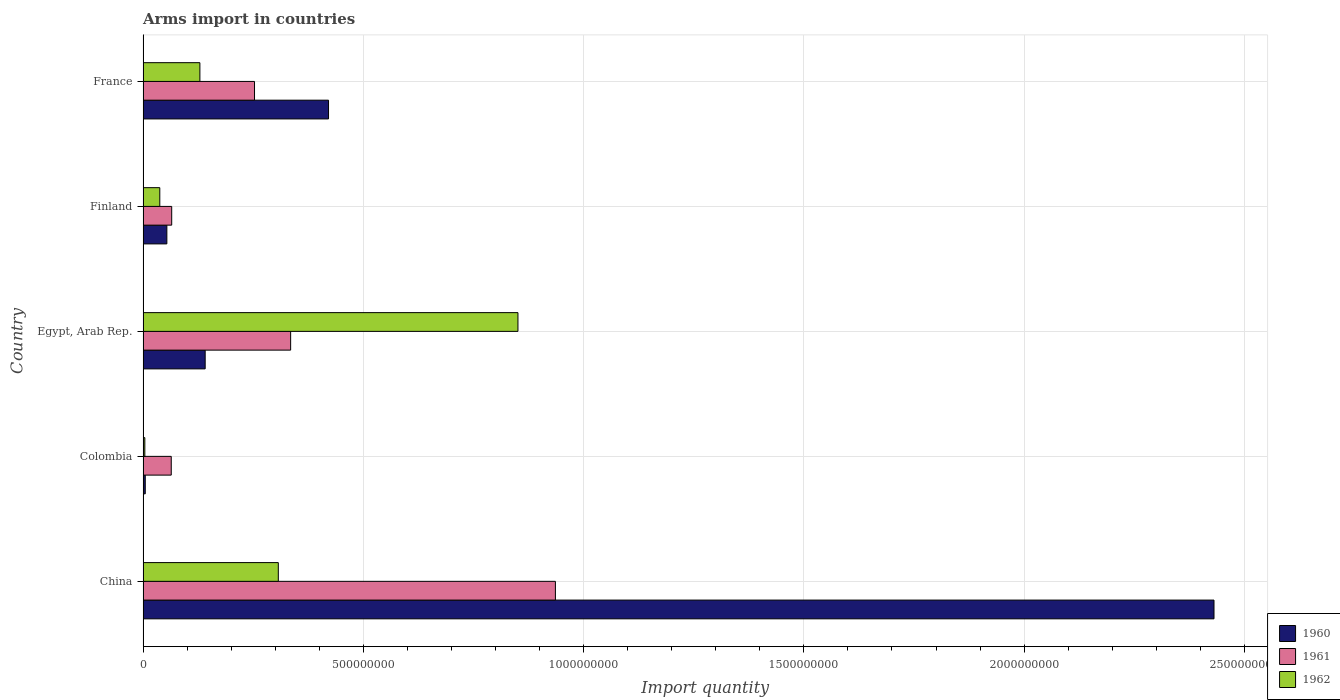How many different coloured bars are there?
Offer a terse response. 3. Are the number of bars per tick equal to the number of legend labels?
Offer a very short reply. Yes. What is the label of the 2nd group of bars from the top?
Give a very brief answer. Finland. In how many cases, is the number of bars for a given country not equal to the number of legend labels?
Your answer should be very brief. 0. What is the total arms import in 1960 in Finland?
Your response must be concise. 5.40e+07. Across all countries, what is the maximum total arms import in 1961?
Offer a very short reply. 9.36e+08. In which country was the total arms import in 1960 minimum?
Your response must be concise. Colombia. What is the total total arms import in 1960 in the graph?
Provide a succinct answer. 3.05e+09. What is the difference between the total arms import in 1960 in China and that in Finland?
Give a very brief answer. 2.38e+09. What is the difference between the total arms import in 1962 in China and the total arms import in 1960 in Colombia?
Your answer should be compact. 3.02e+08. What is the average total arms import in 1962 per country?
Give a very brief answer. 2.66e+08. What is the difference between the total arms import in 1960 and total arms import in 1961 in Egypt, Arab Rep.?
Give a very brief answer. -1.94e+08. In how many countries, is the total arms import in 1962 greater than 1700000000 ?
Keep it short and to the point. 0. What is the ratio of the total arms import in 1960 in Colombia to that in France?
Your answer should be compact. 0.01. What is the difference between the highest and the second highest total arms import in 1962?
Your answer should be compact. 5.44e+08. What is the difference between the highest and the lowest total arms import in 1960?
Give a very brief answer. 2.43e+09. In how many countries, is the total arms import in 1961 greater than the average total arms import in 1961 taken over all countries?
Provide a short and direct response. 2. Is the sum of the total arms import in 1962 in China and Colombia greater than the maximum total arms import in 1961 across all countries?
Ensure brevity in your answer.  No. What does the 1st bar from the top in Finland represents?
Offer a very short reply. 1962. What does the 3rd bar from the bottom in Finland represents?
Offer a very short reply. 1962. How many bars are there?
Your response must be concise. 15. Are all the bars in the graph horizontal?
Your response must be concise. Yes. How many countries are there in the graph?
Make the answer very short. 5. What is the difference between two consecutive major ticks on the X-axis?
Make the answer very short. 5.00e+08. How many legend labels are there?
Provide a short and direct response. 3. How are the legend labels stacked?
Your response must be concise. Vertical. What is the title of the graph?
Make the answer very short. Arms import in countries. What is the label or title of the X-axis?
Your response must be concise. Import quantity. What is the label or title of the Y-axis?
Ensure brevity in your answer.  Country. What is the Import quantity in 1960 in China?
Provide a short and direct response. 2.43e+09. What is the Import quantity in 1961 in China?
Ensure brevity in your answer.  9.36e+08. What is the Import quantity in 1962 in China?
Your response must be concise. 3.07e+08. What is the Import quantity of 1961 in Colombia?
Keep it short and to the point. 6.40e+07. What is the Import quantity of 1962 in Colombia?
Your answer should be very brief. 4.00e+06. What is the Import quantity in 1960 in Egypt, Arab Rep.?
Provide a short and direct response. 1.41e+08. What is the Import quantity of 1961 in Egypt, Arab Rep.?
Offer a terse response. 3.35e+08. What is the Import quantity in 1962 in Egypt, Arab Rep.?
Keep it short and to the point. 8.51e+08. What is the Import quantity in 1960 in Finland?
Provide a succinct answer. 5.40e+07. What is the Import quantity in 1961 in Finland?
Make the answer very short. 6.50e+07. What is the Import quantity in 1962 in Finland?
Make the answer very short. 3.80e+07. What is the Import quantity in 1960 in France?
Keep it short and to the point. 4.21e+08. What is the Import quantity of 1961 in France?
Make the answer very short. 2.53e+08. What is the Import quantity in 1962 in France?
Keep it short and to the point. 1.29e+08. Across all countries, what is the maximum Import quantity in 1960?
Your answer should be very brief. 2.43e+09. Across all countries, what is the maximum Import quantity in 1961?
Offer a terse response. 9.36e+08. Across all countries, what is the maximum Import quantity of 1962?
Your answer should be very brief. 8.51e+08. Across all countries, what is the minimum Import quantity in 1960?
Your response must be concise. 5.00e+06. Across all countries, what is the minimum Import quantity of 1961?
Offer a very short reply. 6.40e+07. Across all countries, what is the minimum Import quantity of 1962?
Offer a very short reply. 4.00e+06. What is the total Import quantity in 1960 in the graph?
Your response must be concise. 3.05e+09. What is the total Import quantity in 1961 in the graph?
Your answer should be compact. 1.65e+09. What is the total Import quantity in 1962 in the graph?
Offer a very short reply. 1.33e+09. What is the difference between the Import quantity in 1960 in China and that in Colombia?
Your response must be concise. 2.43e+09. What is the difference between the Import quantity in 1961 in China and that in Colombia?
Make the answer very short. 8.72e+08. What is the difference between the Import quantity in 1962 in China and that in Colombia?
Provide a succinct answer. 3.03e+08. What is the difference between the Import quantity of 1960 in China and that in Egypt, Arab Rep.?
Your response must be concise. 2.29e+09. What is the difference between the Import quantity in 1961 in China and that in Egypt, Arab Rep.?
Give a very brief answer. 6.01e+08. What is the difference between the Import quantity of 1962 in China and that in Egypt, Arab Rep.?
Your answer should be compact. -5.44e+08. What is the difference between the Import quantity in 1960 in China and that in Finland?
Your answer should be very brief. 2.38e+09. What is the difference between the Import quantity of 1961 in China and that in Finland?
Provide a succinct answer. 8.71e+08. What is the difference between the Import quantity in 1962 in China and that in Finland?
Keep it short and to the point. 2.69e+08. What is the difference between the Import quantity of 1960 in China and that in France?
Ensure brevity in your answer.  2.01e+09. What is the difference between the Import quantity of 1961 in China and that in France?
Make the answer very short. 6.83e+08. What is the difference between the Import quantity of 1962 in China and that in France?
Offer a terse response. 1.78e+08. What is the difference between the Import quantity in 1960 in Colombia and that in Egypt, Arab Rep.?
Offer a terse response. -1.36e+08. What is the difference between the Import quantity of 1961 in Colombia and that in Egypt, Arab Rep.?
Make the answer very short. -2.71e+08. What is the difference between the Import quantity of 1962 in Colombia and that in Egypt, Arab Rep.?
Provide a short and direct response. -8.47e+08. What is the difference between the Import quantity in 1960 in Colombia and that in Finland?
Provide a short and direct response. -4.90e+07. What is the difference between the Import quantity in 1962 in Colombia and that in Finland?
Your answer should be very brief. -3.40e+07. What is the difference between the Import quantity in 1960 in Colombia and that in France?
Your response must be concise. -4.16e+08. What is the difference between the Import quantity in 1961 in Colombia and that in France?
Keep it short and to the point. -1.89e+08. What is the difference between the Import quantity of 1962 in Colombia and that in France?
Give a very brief answer. -1.25e+08. What is the difference between the Import quantity in 1960 in Egypt, Arab Rep. and that in Finland?
Offer a terse response. 8.70e+07. What is the difference between the Import quantity of 1961 in Egypt, Arab Rep. and that in Finland?
Give a very brief answer. 2.70e+08. What is the difference between the Import quantity in 1962 in Egypt, Arab Rep. and that in Finland?
Your response must be concise. 8.13e+08. What is the difference between the Import quantity in 1960 in Egypt, Arab Rep. and that in France?
Ensure brevity in your answer.  -2.80e+08. What is the difference between the Import quantity of 1961 in Egypt, Arab Rep. and that in France?
Ensure brevity in your answer.  8.20e+07. What is the difference between the Import quantity in 1962 in Egypt, Arab Rep. and that in France?
Your response must be concise. 7.22e+08. What is the difference between the Import quantity in 1960 in Finland and that in France?
Offer a terse response. -3.67e+08. What is the difference between the Import quantity in 1961 in Finland and that in France?
Provide a succinct answer. -1.88e+08. What is the difference between the Import quantity in 1962 in Finland and that in France?
Your answer should be compact. -9.10e+07. What is the difference between the Import quantity of 1960 in China and the Import quantity of 1961 in Colombia?
Your response must be concise. 2.37e+09. What is the difference between the Import quantity in 1960 in China and the Import quantity in 1962 in Colombia?
Make the answer very short. 2.43e+09. What is the difference between the Import quantity of 1961 in China and the Import quantity of 1962 in Colombia?
Make the answer very short. 9.32e+08. What is the difference between the Import quantity in 1960 in China and the Import quantity in 1961 in Egypt, Arab Rep.?
Give a very brief answer. 2.10e+09. What is the difference between the Import quantity in 1960 in China and the Import quantity in 1962 in Egypt, Arab Rep.?
Your answer should be very brief. 1.58e+09. What is the difference between the Import quantity of 1961 in China and the Import quantity of 1962 in Egypt, Arab Rep.?
Provide a succinct answer. 8.50e+07. What is the difference between the Import quantity of 1960 in China and the Import quantity of 1961 in Finland?
Provide a short and direct response. 2.37e+09. What is the difference between the Import quantity of 1960 in China and the Import quantity of 1962 in Finland?
Offer a very short reply. 2.39e+09. What is the difference between the Import quantity of 1961 in China and the Import quantity of 1962 in Finland?
Ensure brevity in your answer.  8.98e+08. What is the difference between the Import quantity of 1960 in China and the Import quantity of 1961 in France?
Your response must be concise. 2.18e+09. What is the difference between the Import quantity in 1960 in China and the Import quantity in 1962 in France?
Provide a short and direct response. 2.30e+09. What is the difference between the Import quantity in 1961 in China and the Import quantity in 1962 in France?
Offer a very short reply. 8.07e+08. What is the difference between the Import quantity in 1960 in Colombia and the Import quantity in 1961 in Egypt, Arab Rep.?
Your response must be concise. -3.30e+08. What is the difference between the Import quantity of 1960 in Colombia and the Import quantity of 1962 in Egypt, Arab Rep.?
Give a very brief answer. -8.46e+08. What is the difference between the Import quantity of 1961 in Colombia and the Import quantity of 1962 in Egypt, Arab Rep.?
Your answer should be very brief. -7.87e+08. What is the difference between the Import quantity in 1960 in Colombia and the Import quantity in 1961 in Finland?
Offer a very short reply. -6.00e+07. What is the difference between the Import quantity in 1960 in Colombia and the Import quantity in 1962 in Finland?
Provide a succinct answer. -3.30e+07. What is the difference between the Import quantity in 1961 in Colombia and the Import quantity in 1962 in Finland?
Provide a succinct answer. 2.60e+07. What is the difference between the Import quantity of 1960 in Colombia and the Import quantity of 1961 in France?
Provide a short and direct response. -2.48e+08. What is the difference between the Import quantity of 1960 in Colombia and the Import quantity of 1962 in France?
Ensure brevity in your answer.  -1.24e+08. What is the difference between the Import quantity in 1961 in Colombia and the Import quantity in 1962 in France?
Make the answer very short. -6.50e+07. What is the difference between the Import quantity in 1960 in Egypt, Arab Rep. and the Import quantity in 1961 in Finland?
Offer a very short reply. 7.60e+07. What is the difference between the Import quantity of 1960 in Egypt, Arab Rep. and the Import quantity of 1962 in Finland?
Make the answer very short. 1.03e+08. What is the difference between the Import quantity in 1961 in Egypt, Arab Rep. and the Import quantity in 1962 in Finland?
Provide a short and direct response. 2.97e+08. What is the difference between the Import quantity of 1960 in Egypt, Arab Rep. and the Import quantity of 1961 in France?
Ensure brevity in your answer.  -1.12e+08. What is the difference between the Import quantity in 1961 in Egypt, Arab Rep. and the Import quantity in 1962 in France?
Make the answer very short. 2.06e+08. What is the difference between the Import quantity in 1960 in Finland and the Import quantity in 1961 in France?
Keep it short and to the point. -1.99e+08. What is the difference between the Import quantity of 1960 in Finland and the Import quantity of 1962 in France?
Give a very brief answer. -7.50e+07. What is the difference between the Import quantity of 1961 in Finland and the Import quantity of 1962 in France?
Keep it short and to the point. -6.40e+07. What is the average Import quantity of 1960 per country?
Keep it short and to the point. 6.10e+08. What is the average Import quantity in 1961 per country?
Provide a short and direct response. 3.31e+08. What is the average Import quantity of 1962 per country?
Your answer should be compact. 2.66e+08. What is the difference between the Import quantity of 1960 and Import quantity of 1961 in China?
Give a very brief answer. 1.50e+09. What is the difference between the Import quantity of 1960 and Import quantity of 1962 in China?
Your answer should be compact. 2.12e+09. What is the difference between the Import quantity in 1961 and Import quantity in 1962 in China?
Your answer should be very brief. 6.29e+08. What is the difference between the Import quantity of 1960 and Import quantity of 1961 in Colombia?
Your answer should be compact. -5.90e+07. What is the difference between the Import quantity in 1961 and Import quantity in 1962 in Colombia?
Your answer should be very brief. 6.00e+07. What is the difference between the Import quantity in 1960 and Import quantity in 1961 in Egypt, Arab Rep.?
Ensure brevity in your answer.  -1.94e+08. What is the difference between the Import quantity of 1960 and Import quantity of 1962 in Egypt, Arab Rep.?
Your response must be concise. -7.10e+08. What is the difference between the Import quantity of 1961 and Import quantity of 1962 in Egypt, Arab Rep.?
Ensure brevity in your answer.  -5.16e+08. What is the difference between the Import quantity in 1960 and Import quantity in 1961 in Finland?
Provide a short and direct response. -1.10e+07. What is the difference between the Import quantity in 1960 and Import quantity in 1962 in Finland?
Make the answer very short. 1.60e+07. What is the difference between the Import quantity in 1961 and Import quantity in 1962 in Finland?
Your response must be concise. 2.70e+07. What is the difference between the Import quantity in 1960 and Import quantity in 1961 in France?
Offer a very short reply. 1.68e+08. What is the difference between the Import quantity of 1960 and Import quantity of 1962 in France?
Give a very brief answer. 2.92e+08. What is the difference between the Import quantity of 1961 and Import quantity of 1962 in France?
Your answer should be very brief. 1.24e+08. What is the ratio of the Import quantity in 1960 in China to that in Colombia?
Ensure brevity in your answer.  486.2. What is the ratio of the Import quantity in 1961 in China to that in Colombia?
Provide a short and direct response. 14.62. What is the ratio of the Import quantity in 1962 in China to that in Colombia?
Keep it short and to the point. 76.75. What is the ratio of the Import quantity in 1960 in China to that in Egypt, Arab Rep.?
Keep it short and to the point. 17.24. What is the ratio of the Import quantity of 1961 in China to that in Egypt, Arab Rep.?
Your answer should be compact. 2.79. What is the ratio of the Import quantity of 1962 in China to that in Egypt, Arab Rep.?
Your response must be concise. 0.36. What is the ratio of the Import quantity in 1960 in China to that in Finland?
Provide a succinct answer. 45.02. What is the ratio of the Import quantity in 1961 in China to that in Finland?
Your answer should be very brief. 14.4. What is the ratio of the Import quantity of 1962 in China to that in Finland?
Offer a very short reply. 8.08. What is the ratio of the Import quantity in 1960 in China to that in France?
Your answer should be very brief. 5.77. What is the ratio of the Import quantity of 1961 in China to that in France?
Give a very brief answer. 3.7. What is the ratio of the Import quantity of 1962 in China to that in France?
Your answer should be compact. 2.38. What is the ratio of the Import quantity of 1960 in Colombia to that in Egypt, Arab Rep.?
Keep it short and to the point. 0.04. What is the ratio of the Import quantity in 1961 in Colombia to that in Egypt, Arab Rep.?
Your answer should be very brief. 0.19. What is the ratio of the Import quantity in 1962 in Colombia to that in Egypt, Arab Rep.?
Your answer should be very brief. 0. What is the ratio of the Import quantity of 1960 in Colombia to that in Finland?
Give a very brief answer. 0.09. What is the ratio of the Import quantity of 1961 in Colombia to that in Finland?
Make the answer very short. 0.98. What is the ratio of the Import quantity in 1962 in Colombia to that in Finland?
Provide a succinct answer. 0.11. What is the ratio of the Import quantity in 1960 in Colombia to that in France?
Make the answer very short. 0.01. What is the ratio of the Import quantity of 1961 in Colombia to that in France?
Provide a short and direct response. 0.25. What is the ratio of the Import quantity in 1962 in Colombia to that in France?
Make the answer very short. 0.03. What is the ratio of the Import quantity in 1960 in Egypt, Arab Rep. to that in Finland?
Provide a short and direct response. 2.61. What is the ratio of the Import quantity of 1961 in Egypt, Arab Rep. to that in Finland?
Your response must be concise. 5.15. What is the ratio of the Import quantity of 1962 in Egypt, Arab Rep. to that in Finland?
Offer a very short reply. 22.39. What is the ratio of the Import quantity of 1960 in Egypt, Arab Rep. to that in France?
Keep it short and to the point. 0.33. What is the ratio of the Import quantity in 1961 in Egypt, Arab Rep. to that in France?
Provide a short and direct response. 1.32. What is the ratio of the Import quantity in 1962 in Egypt, Arab Rep. to that in France?
Ensure brevity in your answer.  6.6. What is the ratio of the Import quantity of 1960 in Finland to that in France?
Provide a succinct answer. 0.13. What is the ratio of the Import quantity of 1961 in Finland to that in France?
Make the answer very short. 0.26. What is the ratio of the Import quantity in 1962 in Finland to that in France?
Your answer should be compact. 0.29. What is the difference between the highest and the second highest Import quantity of 1960?
Your answer should be very brief. 2.01e+09. What is the difference between the highest and the second highest Import quantity of 1961?
Your answer should be very brief. 6.01e+08. What is the difference between the highest and the second highest Import quantity in 1962?
Provide a succinct answer. 5.44e+08. What is the difference between the highest and the lowest Import quantity of 1960?
Offer a terse response. 2.43e+09. What is the difference between the highest and the lowest Import quantity of 1961?
Provide a succinct answer. 8.72e+08. What is the difference between the highest and the lowest Import quantity in 1962?
Make the answer very short. 8.47e+08. 